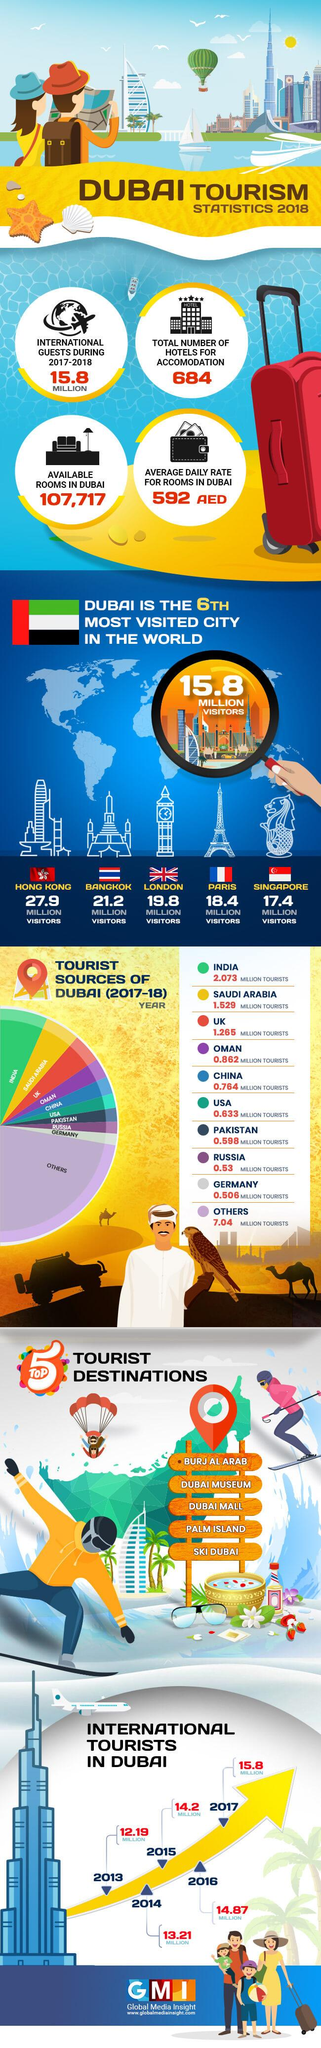Indicate a few pertinent items in this graphic. During 2017-2018, Dubai was visited by the largest number of tourists from India. Hong Kong receives significantly more visitors than Dubai, with a difference of 12.1 million visitors. The number of visitors from Saudi Arabia and the UK differs by 0.264 million visitors. The infographic contains 6 flags. In just four years, the number of international tourists worldwide increased by 3.61 million. 